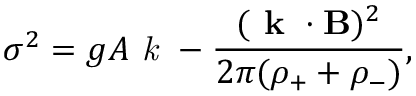<formula> <loc_0><loc_0><loc_500><loc_500>\sigma ^ { 2 } = g A k - \frac { ( k \cdot { B } ) ^ { 2 } } { 2 \pi ( \rho _ { + } + \rho _ { - } ) } ,</formula> 